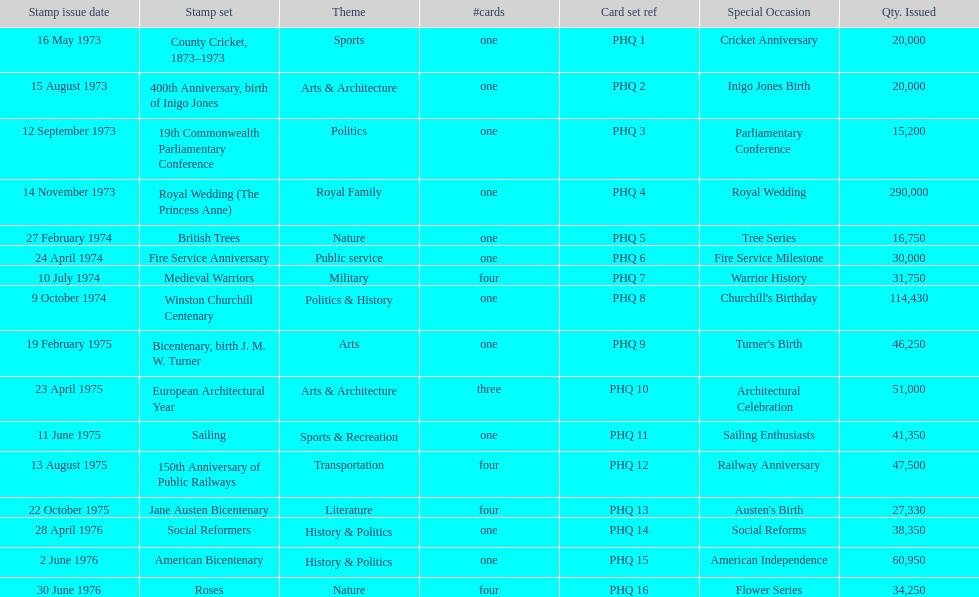Which card was issued most? Royal Wedding (The Princess Anne). 